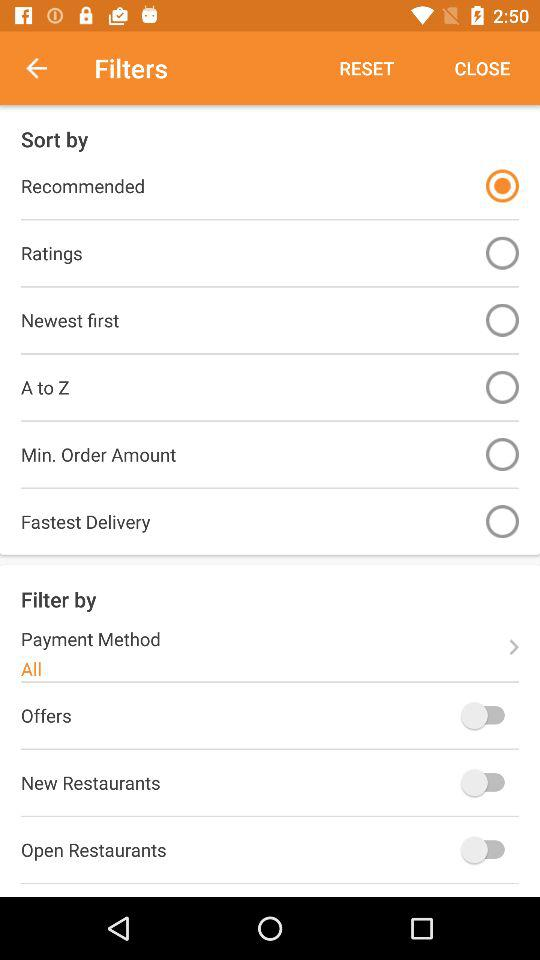What is the status of the "Open Restaurants"? The status is "off". 